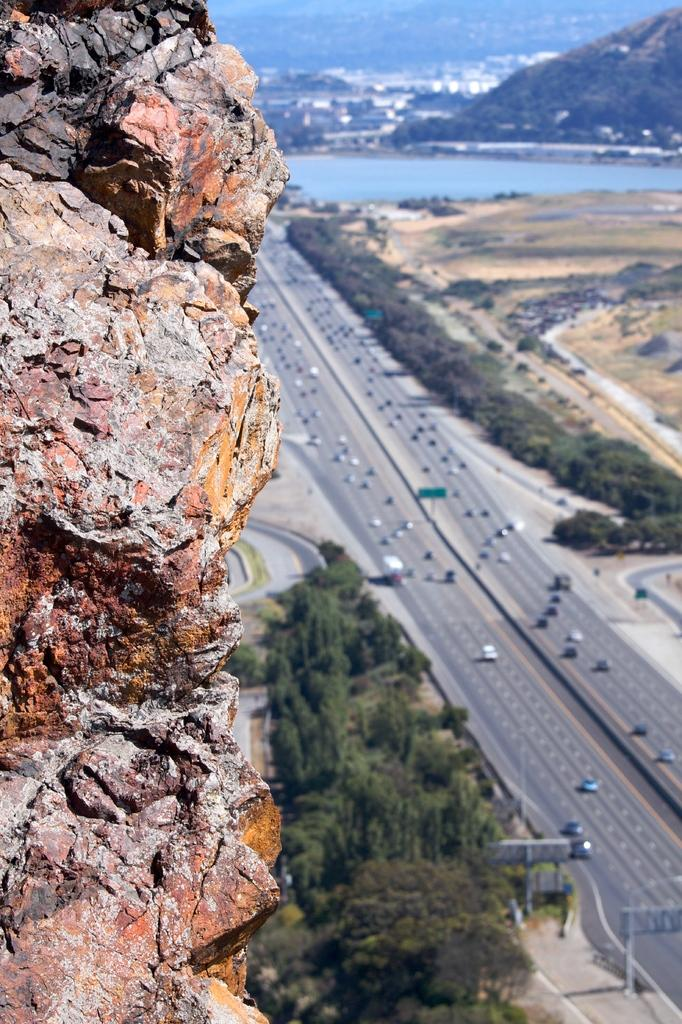What type of natural elements can be seen in the image? There are rocks and trees visible in the image. What man-made objects can be seen in the image? There are vehicles on the road and boards visible in the image. What is the condition of the water in the image? The water is visible in the image. What can be seen in the background of the image? There are mountains in the background of the image. What type of rice can be seen growing near the trees in the image? There is no rice visible in the image; it features rocks, trees, vehicles, boards, water, and mountains. What type of songs can be heard coming from the mountains in the image? There is no indication of any sounds, including songs, in the image. 